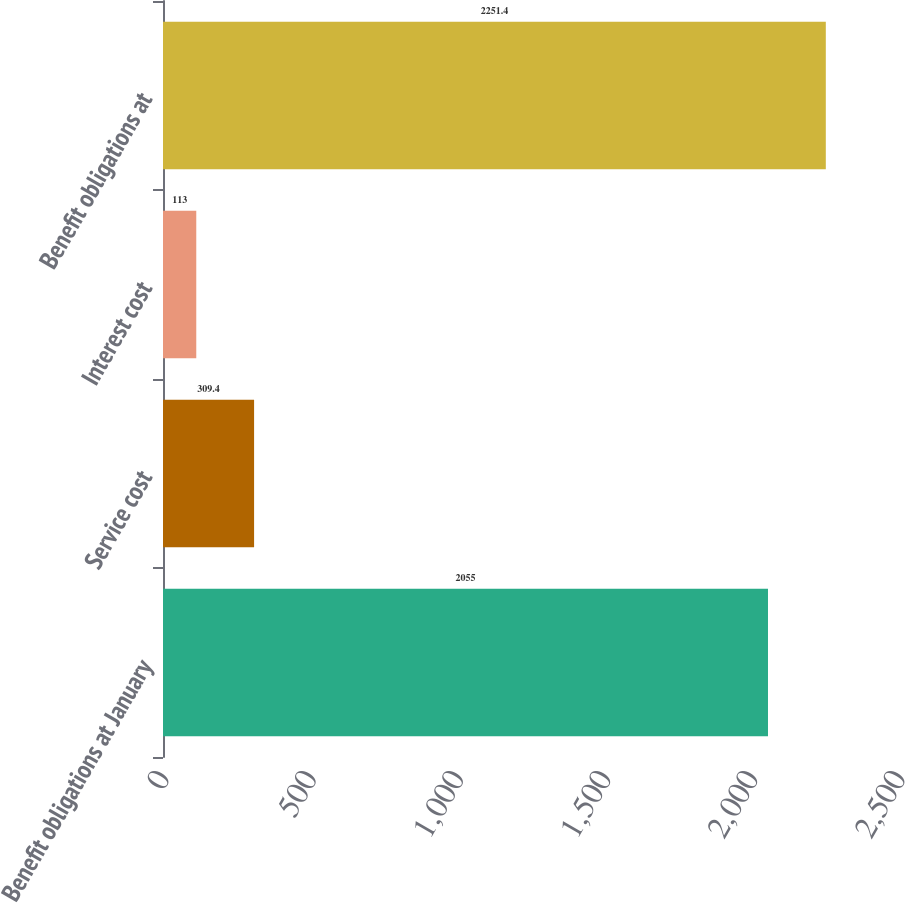<chart> <loc_0><loc_0><loc_500><loc_500><bar_chart><fcel>Benefit obligations at January<fcel>Service cost<fcel>Interest cost<fcel>Benefit obligations at<nl><fcel>2055<fcel>309.4<fcel>113<fcel>2251.4<nl></chart> 